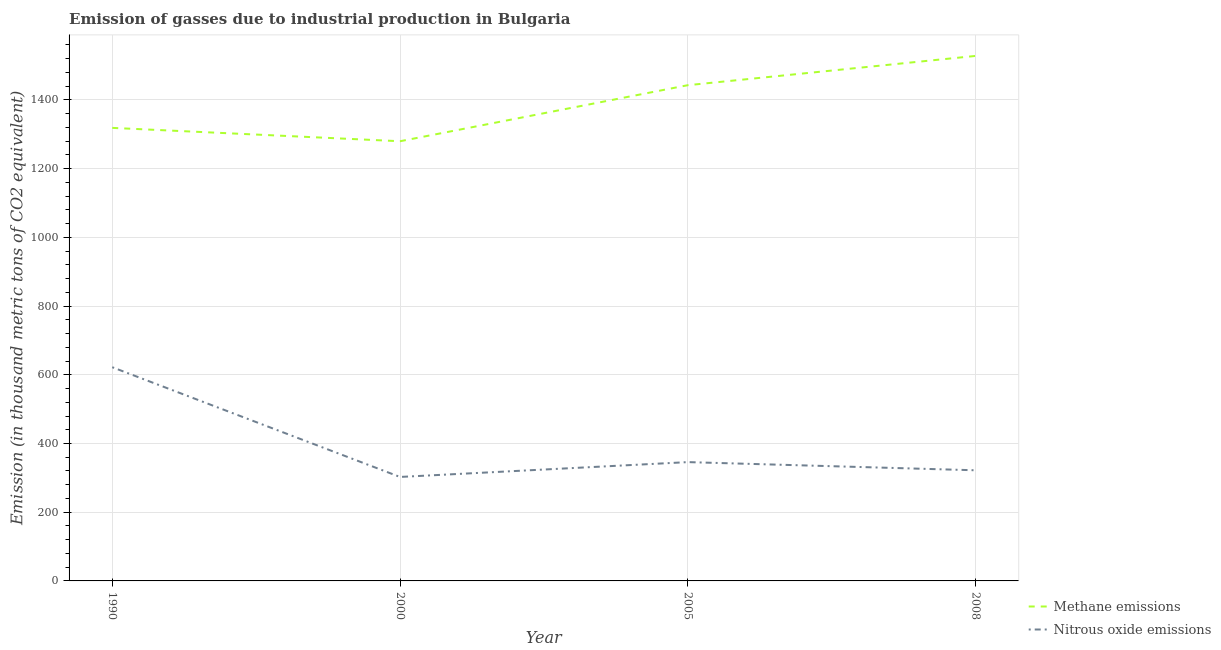What is the amount of nitrous oxide emissions in 2005?
Make the answer very short. 345.8. Across all years, what is the maximum amount of nitrous oxide emissions?
Ensure brevity in your answer.  622. Across all years, what is the minimum amount of nitrous oxide emissions?
Your answer should be compact. 302.6. In which year was the amount of methane emissions minimum?
Make the answer very short. 2000. What is the total amount of methane emissions in the graph?
Provide a succinct answer. 5569.1. What is the difference between the amount of nitrous oxide emissions in 1990 and that in 2000?
Keep it short and to the point. 319.4. What is the difference between the amount of nitrous oxide emissions in 2008 and the amount of methane emissions in 1990?
Your answer should be compact. -996.6. What is the average amount of nitrous oxide emissions per year?
Your answer should be very brief. 398.1. In the year 2005, what is the difference between the amount of methane emissions and amount of nitrous oxide emissions?
Provide a succinct answer. 1097. In how many years, is the amount of methane emissions greater than 720 thousand metric tons?
Offer a terse response. 4. What is the ratio of the amount of nitrous oxide emissions in 1990 to that in 2008?
Make the answer very short. 1.93. Is the amount of nitrous oxide emissions in 2000 less than that in 2005?
Make the answer very short. Yes. What is the difference between the highest and the second highest amount of methane emissions?
Keep it short and to the point. 85.2. What is the difference between the highest and the lowest amount of methane emissions?
Your answer should be very brief. 248.3. Is the sum of the amount of methane emissions in 1990 and 2008 greater than the maximum amount of nitrous oxide emissions across all years?
Give a very brief answer. Yes. Is the amount of nitrous oxide emissions strictly greater than the amount of methane emissions over the years?
Make the answer very short. No. Does the graph contain grids?
Your response must be concise. Yes. Where does the legend appear in the graph?
Offer a terse response. Bottom right. How many legend labels are there?
Your response must be concise. 2. What is the title of the graph?
Provide a succinct answer. Emission of gasses due to industrial production in Bulgaria. What is the label or title of the Y-axis?
Your response must be concise. Emission (in thousand metric tons of CO2 equivalent). What is the Emission (in thousand metric tons of CO2 equivalent) in Methane emissions in 1990?
Give a very brief answer. 1318.6. What is the Emission (in thousand metric tons of CO2 equivalent) of Nitrous oxide emissions in 1990?
Give a very brief answer. 622. What is the Emission (in thousand metric tons of CO2 equivalent) in Methane emissions in 2000?
Provide a short and direct response. 1279.7. What is the Emission (in thousand metric tons of CO2 equivalent) of Nitrous oxide emissions in 2000?
Provide a short and direct response. 302.6. What is the Emission (in thousand metric tons of CO2 equivalent) of Methane emissions in 2005?
Offer a very short reply. 1442.8. What is the Emission (in thousand metric tons of CO2 equivalent) in Nitrous oxide emissions in 2005?
Provide a succinct answer. 345.8. What is the Emission (in thousand metric tons of CO2 equivalent) in Methane emissions in 2008?
Your answer should be very brief. 1528. What is the Emission (in thousand metric tons of CO2 equivalent) in Nitrous oxide emissions in 2008?
Offer a very short reply. 322. Across all years, what is the maximum Emission (in thousand metric tons of CO2 equivalent) in Methane emissions?
Give a very brief answer. 1528. Across all years, what is the maximum Emission (in thousand metric tons of CO2 equivalent) of Nitrous oxide emissions?
Offer a terse response. 622. Across all years, what is the minimum Emission (in thousand metric tons of CO2 equivalent) of Methane emissions?
Keep it short and to the point. 1279.7. Across all years, what is the minimum Emission (in thousand metric tons of CO2 equivalent) of Nitrous oxide emissions?
Give a very brief answer. 302.6. What is the total Emission (in thousand metric tons of CO2 equivalent) of Methane emissions in the graph?
Offer a terse response. 5569.1. What is the total Emission (in thousand metric tons of CO2 equivalent) of Nitrous oxide emissions in the graph?
Keep it short and to the point. 1592.4. What is the difference between the Emission (in thousand metric tons of CO2 equivalent) of Methane emissions in 1990 and that in 2000?
Offer a terse response. 38.9. What is the difference between the Emission (in thousand metric tons of CO2 equivalent) of Nitrous oxide emissions in 1990 and that in 2000?
Provide a succinct answer. 319.4. What is the difference between the Emission (in thousand metric tons of CO2 equivalent) of Methane emissions in 1990 and that in 2005?
Your response must be concise. -124.2. What is the difference between the Emission (in thousand metric tons of CO2 equivalent) of Nitrous oxide emissions in 1990 and that in 2005?
Offer a terse response. 276.2. What is the difference between the Emission (in thousand metric tons of CO2 equivalent) of Methane emissions in 1990 and that in 2008?
Provide a short and direct response. -209.4. What is the difference between the Emission (in thousand metric tons of CO2 equivalent) of Nitrous oxide emissions in 1990 and that in 2008?
Your answer should be compact. 300. What is the difference between the Emission (in thousand metric tons of CO2 equivalent) in Methane emissions in 2000 and that in 2005?
Your response must be concise. -163.1. What is the difference between the Emission (in thousand metric tons of CO2 equivalent) in Nitrous oxide emissions in 2000 and that in 2005?
Ensure brevity in your answer.  -43.2. What is the difference between the Emission (in thousand metric tons of CO2 equivalent) of Methane emissions in 2000 and that in 2008?
Provide a succinct answer. -248.3. What is the difference between the Emission (in thousand metric tons of CO2 equivalent) in Nitrous oxide emissions in 2000 and that in 2008?
Provide a short and direct response. -19.4. What is the difference between the Emission (in thousand metric tons of CO2 equivalent) in Methane emissions in 2005 and that in 2008?
Make the answer very short. -85.2. What is the difference between the Emission (in thousand metric tons of CO2 equivalent) in Nitrous oxide emissions in 2005 and that in 2008?
Ensure brevity in your answer.  23.8. What is the difference between the Emission (in thousand metric tons of CO2 equivalent) of Methane emissions in 1990 and the Emission (in thousand metric tons of CO2 equivalent) of Nitrous oxide emissions in 2000?
Ensure brevity in your answer.  1016. What is the difference between the Emission (in thousand metric tons of CO2 equivalent) of Methane emissions in 1990 and the Emission (in thousand metric tons of CO2 equivalent) of Nitrous oxide emissions in 2005?
Provide a succinct answer. 972.8. What is the difference between the Emission (in thousand metric tons of CO2 equivalent) of Methane emissions in 1990 and the Emission (in thousand metric tons of CO2 equivalent) of Nitrous oxide emissions in 2008?
Offer a terse response. 996.6. What is the difference between the Emission (in thousand metric tons of CO2 equivalent) in Methane emissions in 2000 and the Emission (in thousand metric tons of CO2 equivalent) in Nitrous oxide emissions in 2005?
Your response must be concise. 933.9. What is the difference between the Emission (in thousand metric tons of CO2 equivalent) in Methane emissions in 2000 and the Emission (in thousand metric tons of CO2 equivalent) in Nitrous oxide emissions in 2008?
Give a very brief answer. 957.7. What is the difference between the Emission (in thousand metric tons of CO2 equivalent) of Methane emissions in 2005 and the Emission (in thousand metric tons of CO2 equivalent) of Nitrous oxide emissions in 2008?
Your answer should be very brief. 1120.8. What is the average Emission (in thousand metric tons of CO2 equivalent) in Methane emissions per year?
Make the answer very short. 1392.28. What is the average Emission (in thousand metric tons of CO2 equivalent) in Nitrous oxide emissions per year?
Ensure brevity in your answer.  398.1. In the year 1990, what is the difference between the Emission (in thousand metric tons of CO2 equivalent) of Methane emissions and Emission (in thousand metric tons of CO2 equivalent) of Nitrous oxide emissions?
Your answer should be compact. 696.6. In the year 2000, what is the difference between the Emission (in thousand metric tons of CO2 equivalent) in Methane emissions and Emission (in thousand metric tons of CO2 equivalent) in Nitrous oxide emissions?
Provide a short and direct response. 977.1. In the year 2005, what is the difference between the Emission (in thousand metric tons of CO2 equivalent) in Methane emissions and Emission (in thousand metric tons of CO2 equivalent) in Nitrous oxide emissions?
Give a very brief answer. 1097. In the year 2008, what is the difference between the Emission (in thousand metric tons of CO2 equivalent) in Methane emissions and Emission (in thousand metric tons of CO2 equivalent) in Nitrous oxide emissions?
Keep it short and to the point. 1206. What is the ratio of the Emission (in thousand metric tons of CO2 equivalent) in Methane emissions in 1990 to that in 2000?
Your answer should be compact. 1.03. What is the ratio of the Emission (in thousand metric tons of CO2 equivalent) of Nitrous oxide emissions in 1990 to that in 2000?
Give a very brief answer. 2.06. What is the ratio of the Emission (in thousand metric tons of CO2 equivalent) in Methane emissions in 1990 to that in 2005?
Provide a succinct answer. 0.91. What is the ratio of the Emission (in thousand metric tons of CO2 equivalent) of Nitrous oxide emissions in 1990 to that in 2005?
Your answer should be very brief. 1.8. What is the ratio of the Emission (in thousand metric tons of CO2 equivalent) in Methane emissions in 1990 to that in 2008?
Your response must be concise. 0.86. What is the ratio of the Emission (in thousand metric tons of CO2 equivalent) of Nitrous oxide emissions in 1990 to that in 2008?
Offer a very short reply. 1.93. What is the ratio of the Emission (in thousand metric tons of CO2 equivalent) of Methane emissions in 2000 to that in 2005?
Keep it short and to the point. 0.89. What is the ratio of the Emission (in thousand metric tons of CO2 equivalent) in Nitrous oxide emissions in 2000 to that in 2005?
Ensure brevity in your answer.  0.88. What is the ratio of the Emission (in thousand metric tons of CO2 equivalent) of Methane emissions in 2000 to that in 2008?
Your answer should be compact. 0.84. What is the ratio of the Emission (in thousand metric tons of CO2 equivalent) in Nitrous oxide emissions in 2000 to that in 2008?
Offer a terse response. 0.94. What is the ratio of the Emission (in thousand metric tons of CO2 equivalent) of Methane emissions in 2005 to that in 2008?
Keep it short and to the point. 0.94. What is the ratio of the Emission (in thousand metric tons of CO2 equivalent) in Nitrous oxide emissions in 2005 to that in 2008?
Make the answer very short. 1.07. What is the difference between the highest and the second highest Emission (in thousand metric tons of CO2 equivalent) of Methane emissions?
Make the answer very short. 85.2. What is the difference between the highest and the second highest Emission (in thousand metric tons of CO2 equivalent) in Nitrous oxide emissions?
Keep it short and to the point. 276.2. What is the difference between the highest and the lowest Emission (in thousand metric tons of CO2 equivalent) in Methane emissions?
Ensure brevity in your answer.  248.3. What is the difference between the highest and the lowest Emission (in thousand metric tons of CO2 equivalent) in Nitrous oxide emissions?
Ensure brevity in your answer.  319.4. 